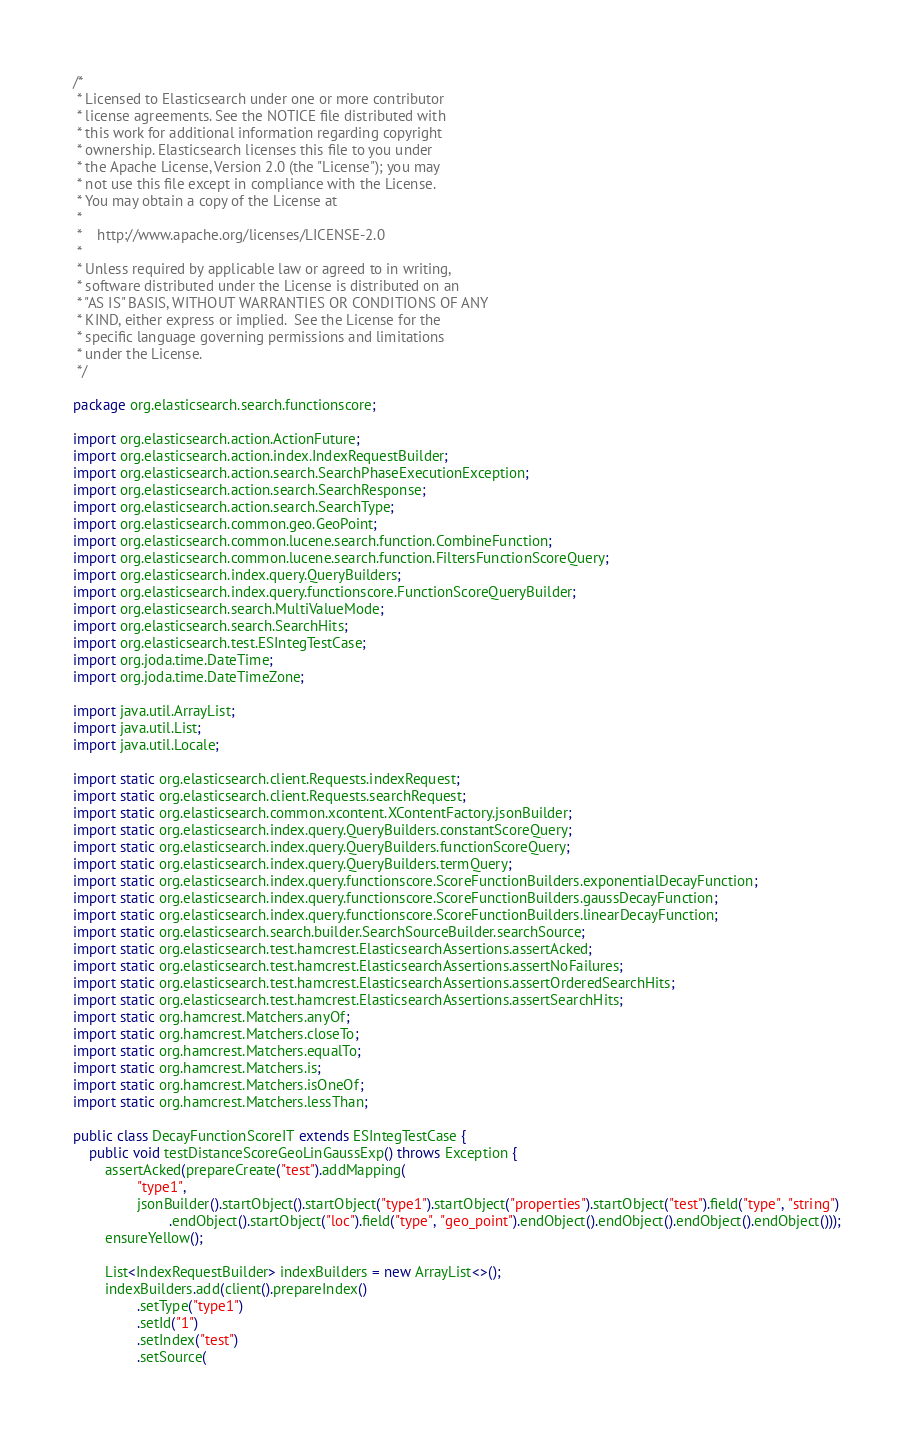<code> <loc_0><loc_0><loc_500><loc_500><_Java_>/*
 * Licensed to Elasticsearch under one or more contributor
 * license agreements. See the NOTICE file distributed with
 * this work for additional information regarding copyright
 * ownership. Elasticsearch licenses this file to you under
 * the Apache License, Version 2.0 (the "License"); you may
 * not use this file except in compliance with the License.
 * You may obtain a copy of the License at
 *
 *    http://www.apache.org/licenses/LICENSE-2.0
 *
 * Unless required by applicable law or agreed to in writing,
 * software distributed under the License is distributed on an
 * "AS IS" BASIS, WITHOUT WARRANTIES OR CONDITIONS OF ANY
 * KIND, either express or implied.  See the License for the
 * specific language governing permissions and limitations
 * under the License.
 */

package org.elasticsearch.search.functionscore;

import org.elasticsearch.action.ActionFuture;
import org.elasticsearch.action.index.IndexRequestBuilder;
import org.elasticsearch.action.search.SearchPhaseExecutionException;
import org.elasticsearch.action.search.SearchResponse;
import org.elasticsearch.action.search.SearchType;
import org.elasticsearch.common.geo.GeoPoint;
import org.elasticsearch.common.lucene.search.function.CombineFunction;
import org.elasticsearch.common.lucene.search.function.FiltersFunctionScoreQuery;
import org.elasticsearch.index.query.QueryBuilders;
import org.elasticsearch.index.query.functionscore.FunctionScoreQueryBuilder;
import org.elasticsearch.search.MultiValueMode;
import org.elasticsearch.search.SearchHits;
import org.elasticsearch.test.ESIntegTestCase;
import org.joda.time.DateTime;
import org.joda.time.DateTimeZone;

import java.util.ArrayList;
import java.util.List;
import java.util.Locale;

import static org.elasticsearch.client.Requests.indexRequest;
import static org.elasticsearch.client.Requests.searchRequest;
import static org.elasticsearch.common.xcontent.XContentFactory.jsonBuilder;
import static org.elasticsearch.index.query.QueryBuilders.constantScoreQuery;
import static org.elasticsearch.index.query.QueryBuilders.functionScoreQuery;
import static org.elasticsearch.index.query.QueryBuilders.termQuery;
import static org.elasticsearch.index.query.functionscore.ScoreFunctionBuilders.exponentialDecayFunction;
import static org.elasticsearch.index.query.functionscore.ScoreFunctionBuilders.gaussDecayFunction;
import static org.elasticsearch.index.query.functionscore.ScoreFunctionBuilders.linearDecayFunction;
import static org.elasticsearch.search.builder.SearchSourceBuilder.searchSource;
import static org.elasticsearch.test.hamcrest.ElasticsearchAssertions.assertAcked;
import static org.elasticsearch.test.hamcrest.ElasticsearchAssertions.assertNoFailures;
import static org.elasticsearch.test.hamcrest.ElasticsearchAssertions.assertOrderedSearchHits;
import static org.elasticsearch.test.hamcrest.ElasticsearchAssertions.assertSearchHits;
import static org.hamcrest.Matchers.anyOf;
import static org.hamcrest.Matchers.closeTo;
import static org.hamcrest.Matchers.equalTo;
import static org.hamcrest.Matchers.is;
import static org.hamcrest.Matchers.isOneOf;
import static org.hamcrest.Matchers.lessThan;

public class DecayFunctionScoreIT extends ESIntegTestCase {
    public void testDistanceScoreGeoLinGaussExp() throws Exception {
        assertAcked(prepareCreate("test").addMapping(
                "type1",
                jsonBuilder().startObject().startObject("type1").startObject("properties").startObject("test").field("type", "string")
                        .endObject().startObject("loc").field("type", "geo_point").endObject().endObject().endObject().endObject()));
        ensureYellow();

        List<IndexRequestBuilder> indexBuilders = new ArrayList<>();
        indexBuilders.add(client().prepareIndex()
                .setType("type1")
                .setId("1")
                .setIndex("test")
                .setSource(</code> 